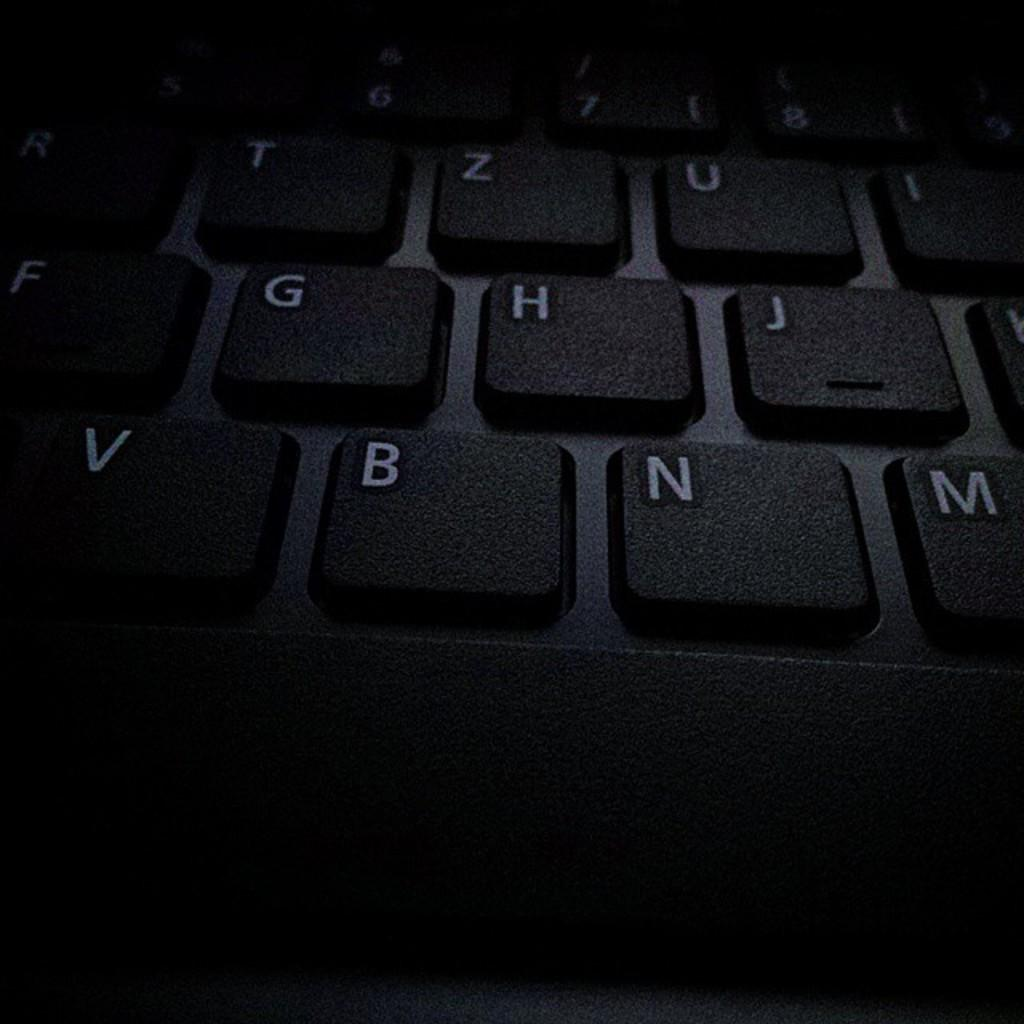<image>
Share a concise interpretation of the image provided. A dark hued view of a keyboard including the B and N keys. 